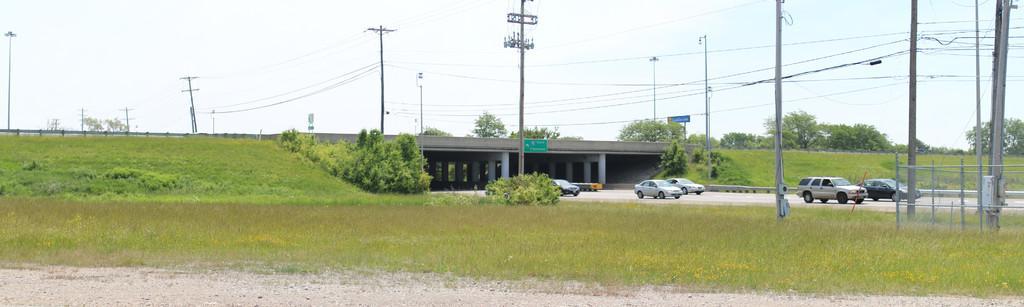Could you give a brief overview of what you see in this image? In this picture we can see ground, grass, plants and trees. We can see vehicles on the road, bridge, pillars, boards, poles and wires. In the background of the image we can see the sky. 